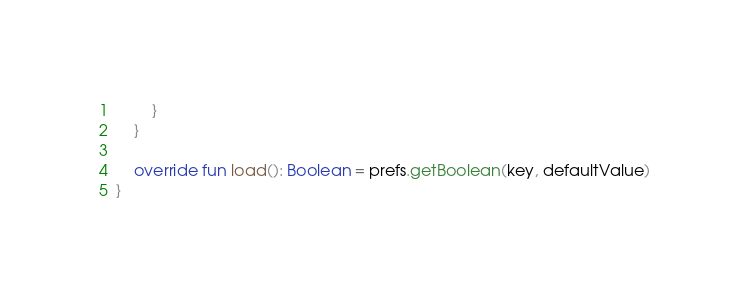Convert code to text. <code><loc_0><loc_0><loc_500><loc_500><_Kotlin_>        }
    }

    override fun load(): Boolean = prefs.getBoolean(key, defaultValue)
}</code> 